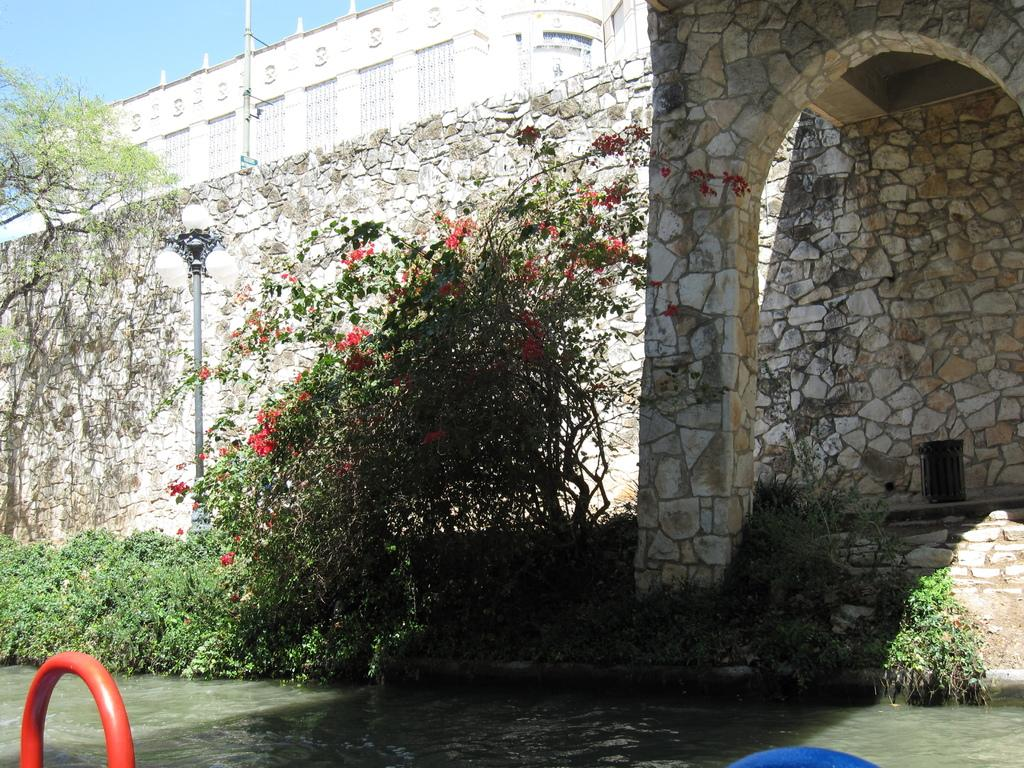What type of structure can be seen in the image? There is a building in the image. What are the tall, vertical objects in the image? Light poles are visible in the image. What type of vegetation is present in the image? Trees and creepers are in the image. What type of barrier is in the image? There is a fencing wall in the image. What is visible at the bottom of the image? Water is visible at the bottom of the image. What part of the natural environment is visible in the image? The sky is visible in the image. Can you describe any other objects in the image? There are other objects in the image, but their specific details are not mentioned in the provided facts. What type of muscle is visible in the image? There is no muscle visible in the image. What type of border is depicted in the image? The provided facts do not mention any borders in the image. 